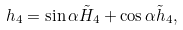<formula> <loc_0><loc_0><loc_500><loc_500>h _ { 4 } = \sin \alpha \tilde { H } _ { 4 } + \cos \alpha \tilde { h } _ { 4 } ,</formula> 